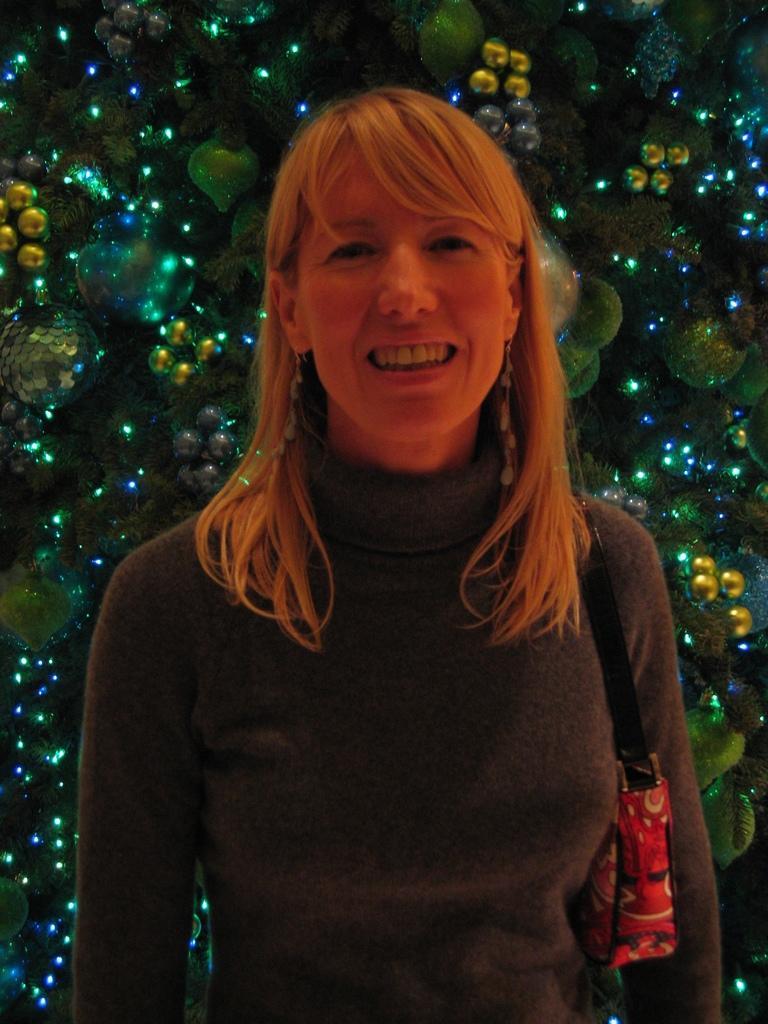Could you give a brief overview of what you see in this image? There is a woman standing and smiling and wire bag. Background we can see decorative items with lights. 